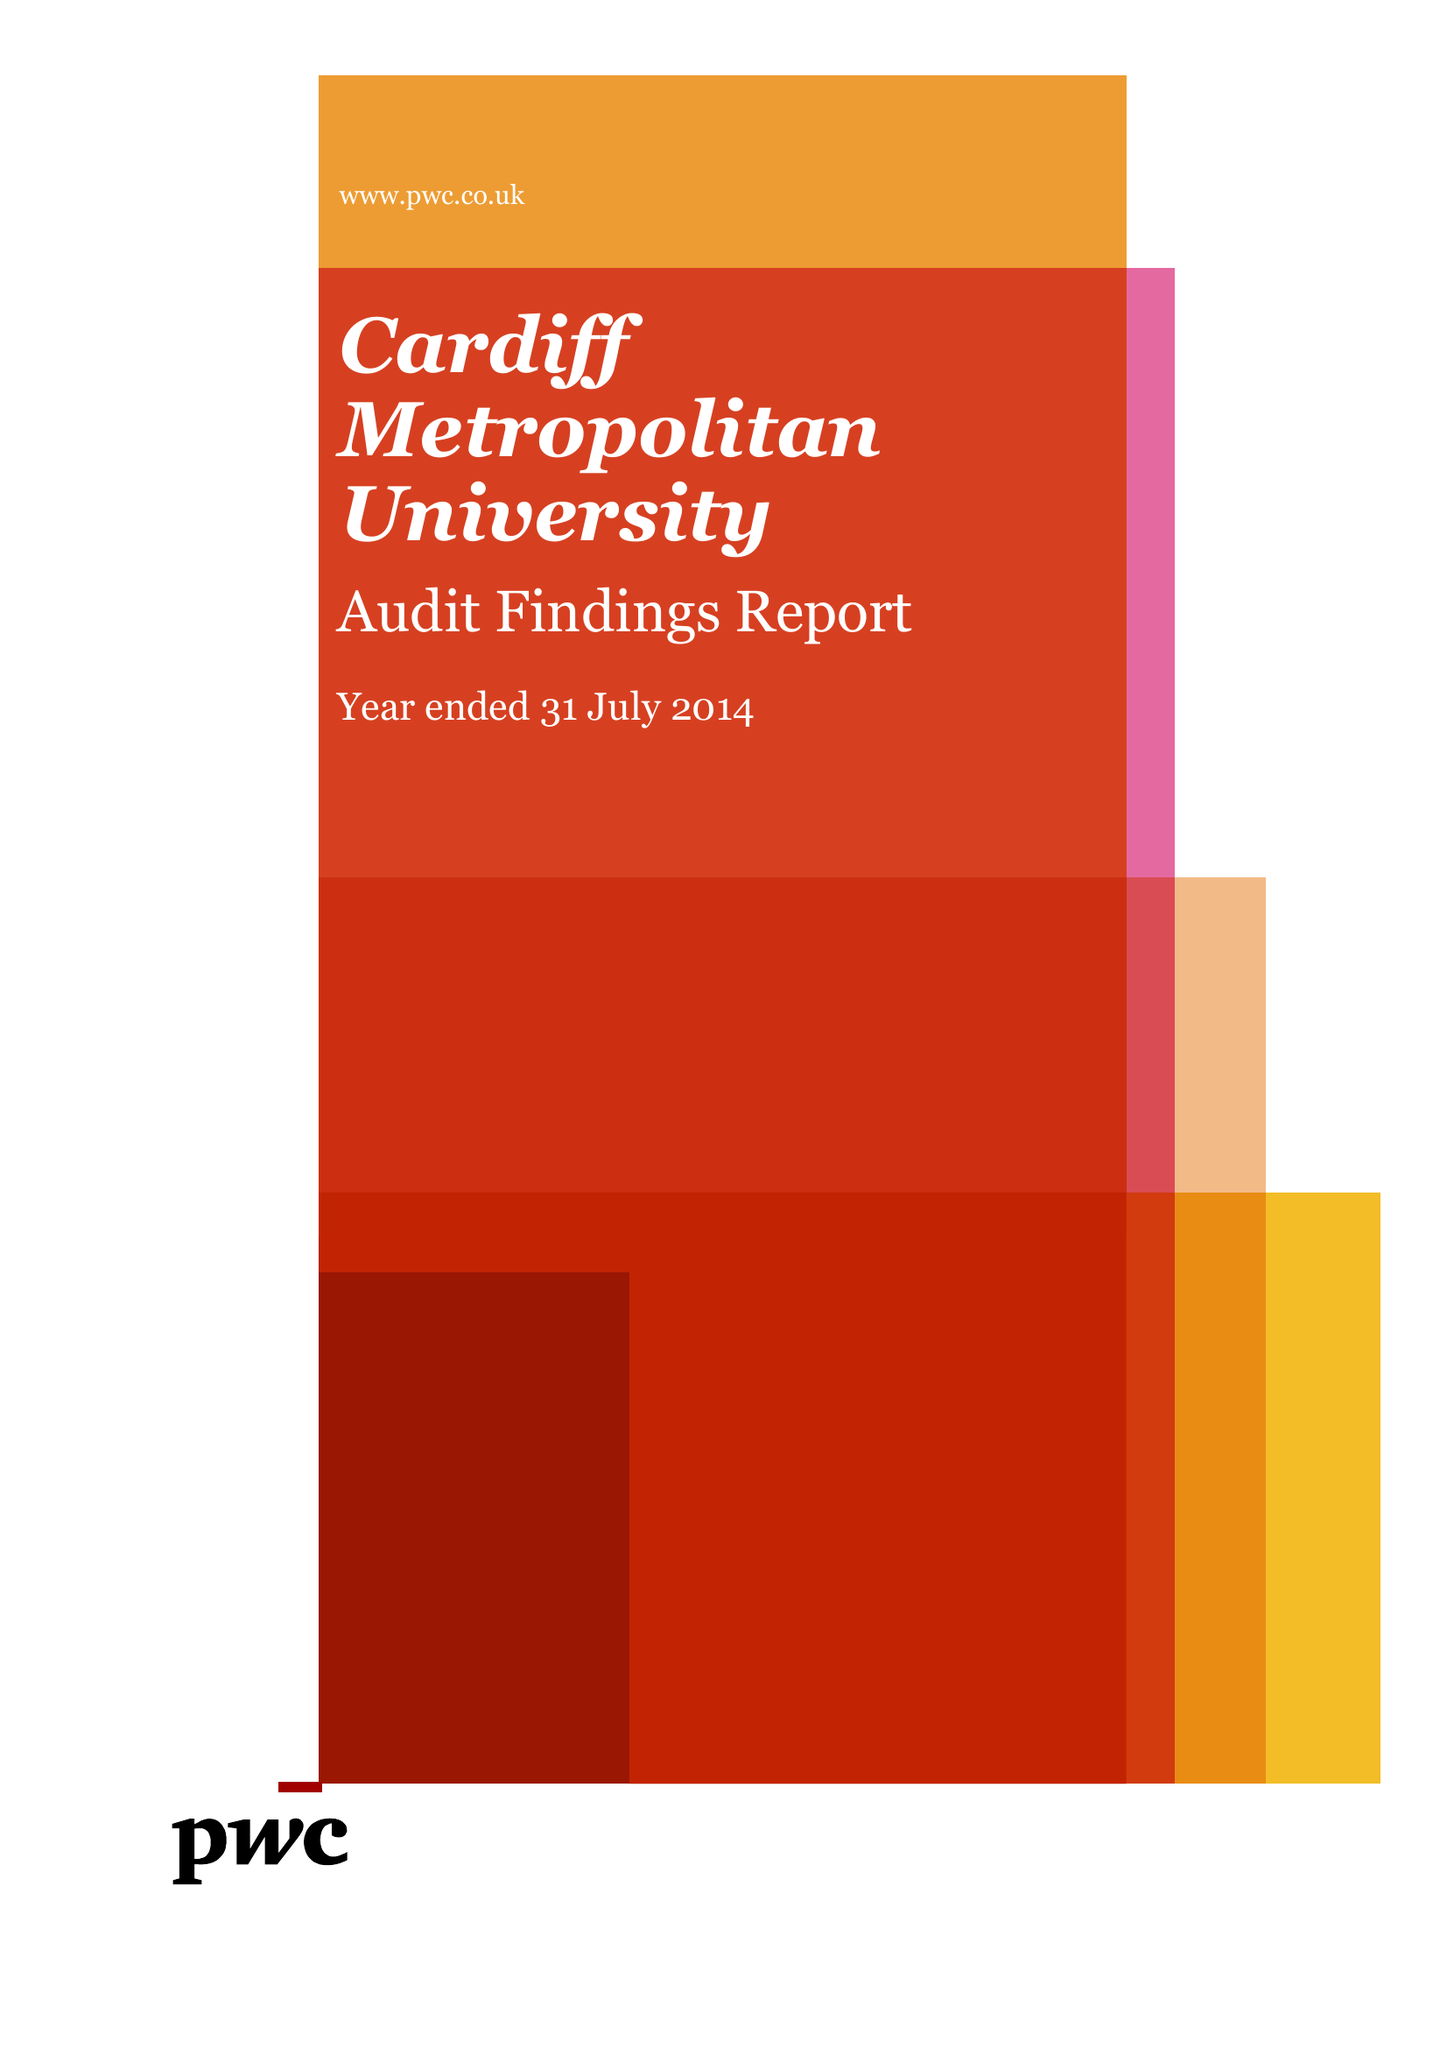What is the value for the income_annually_in_british_pounds?
Answer the question using a single word or phrase. 87158000.00 